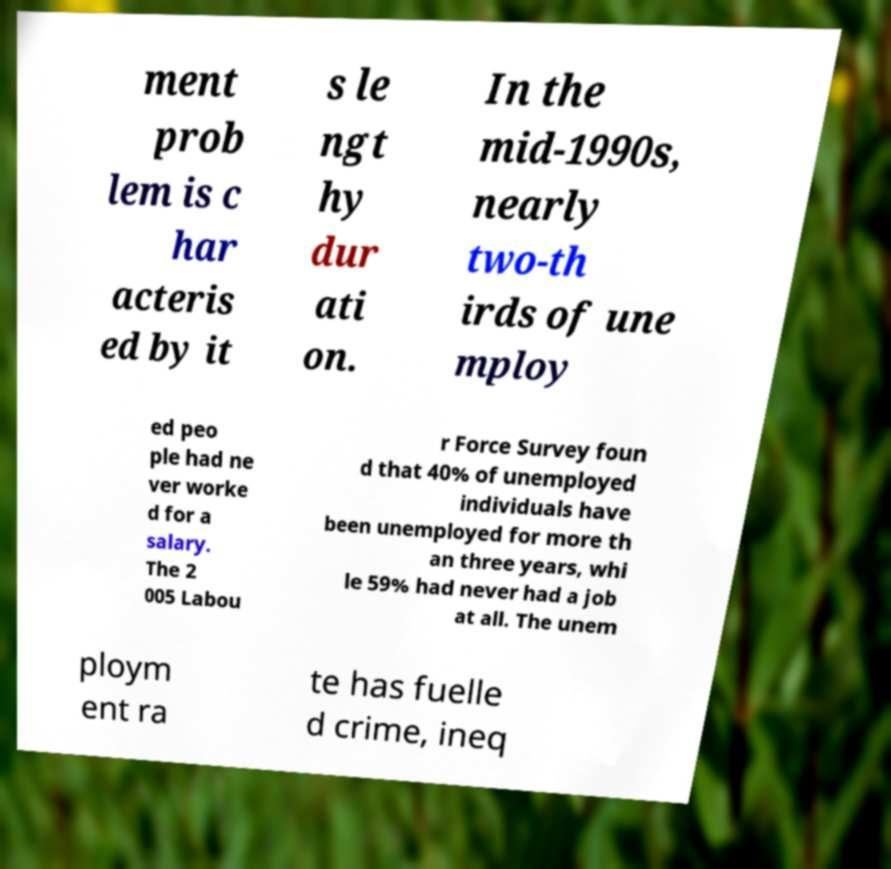Could you assist in decoding the text presented in this image and type it out clearly? ment prob lem is c har acteris ed by it s le ngt hy dur ati on. In the mid-1990s, nearly two-th irds of une mploy ed peo ple had ne ver worke d for a salary. The 2 005 Labou r Force Survey foun d that 40% of unemployed individuals have been unemployed for more th an three years, whi le 59% had never had a job at all. The unem ploym ent ra te has fuelle d crime, ineq 